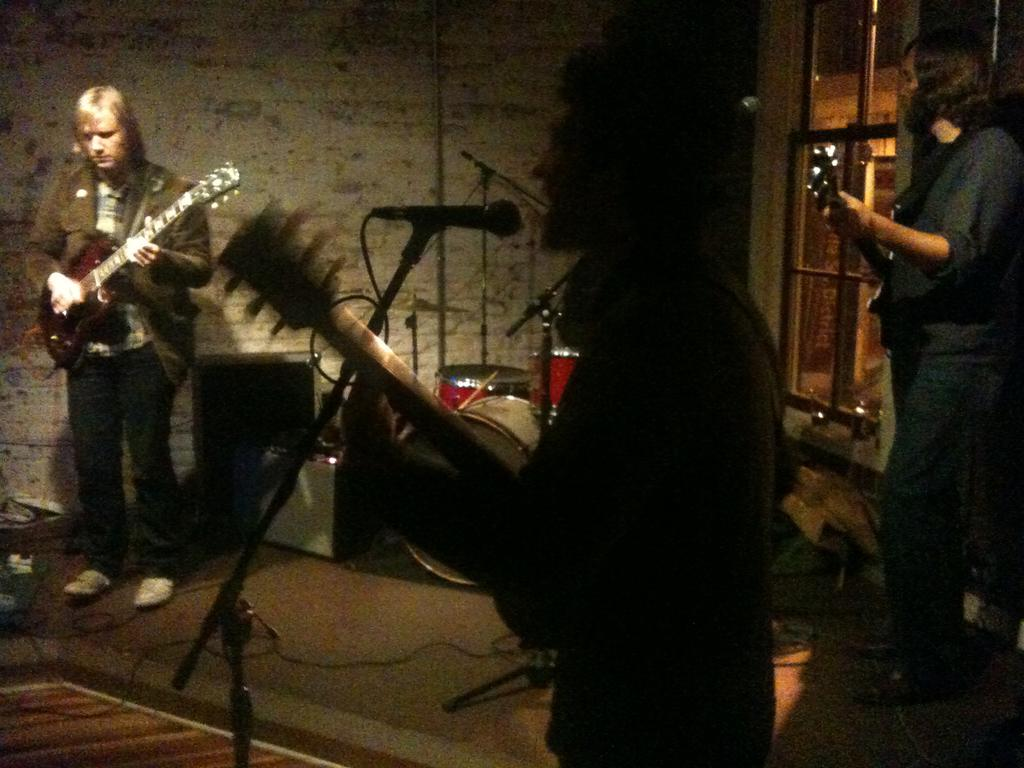What is the main subject of the image? The main subject of the image is a group of people. What are the people in the image doing? The people in the image are musicians. What are the musicians doing in the image? The musicians are playing instruments. What is present in front of the musicians in the image? There is a microphone in front of the musicians. What else can be seen in the image related to music? There are music instruments visible in the image. How many boys are present in the image? The provided facts do not mention the gender of the people in the image, so it is impossible to determine the number of boys present. 